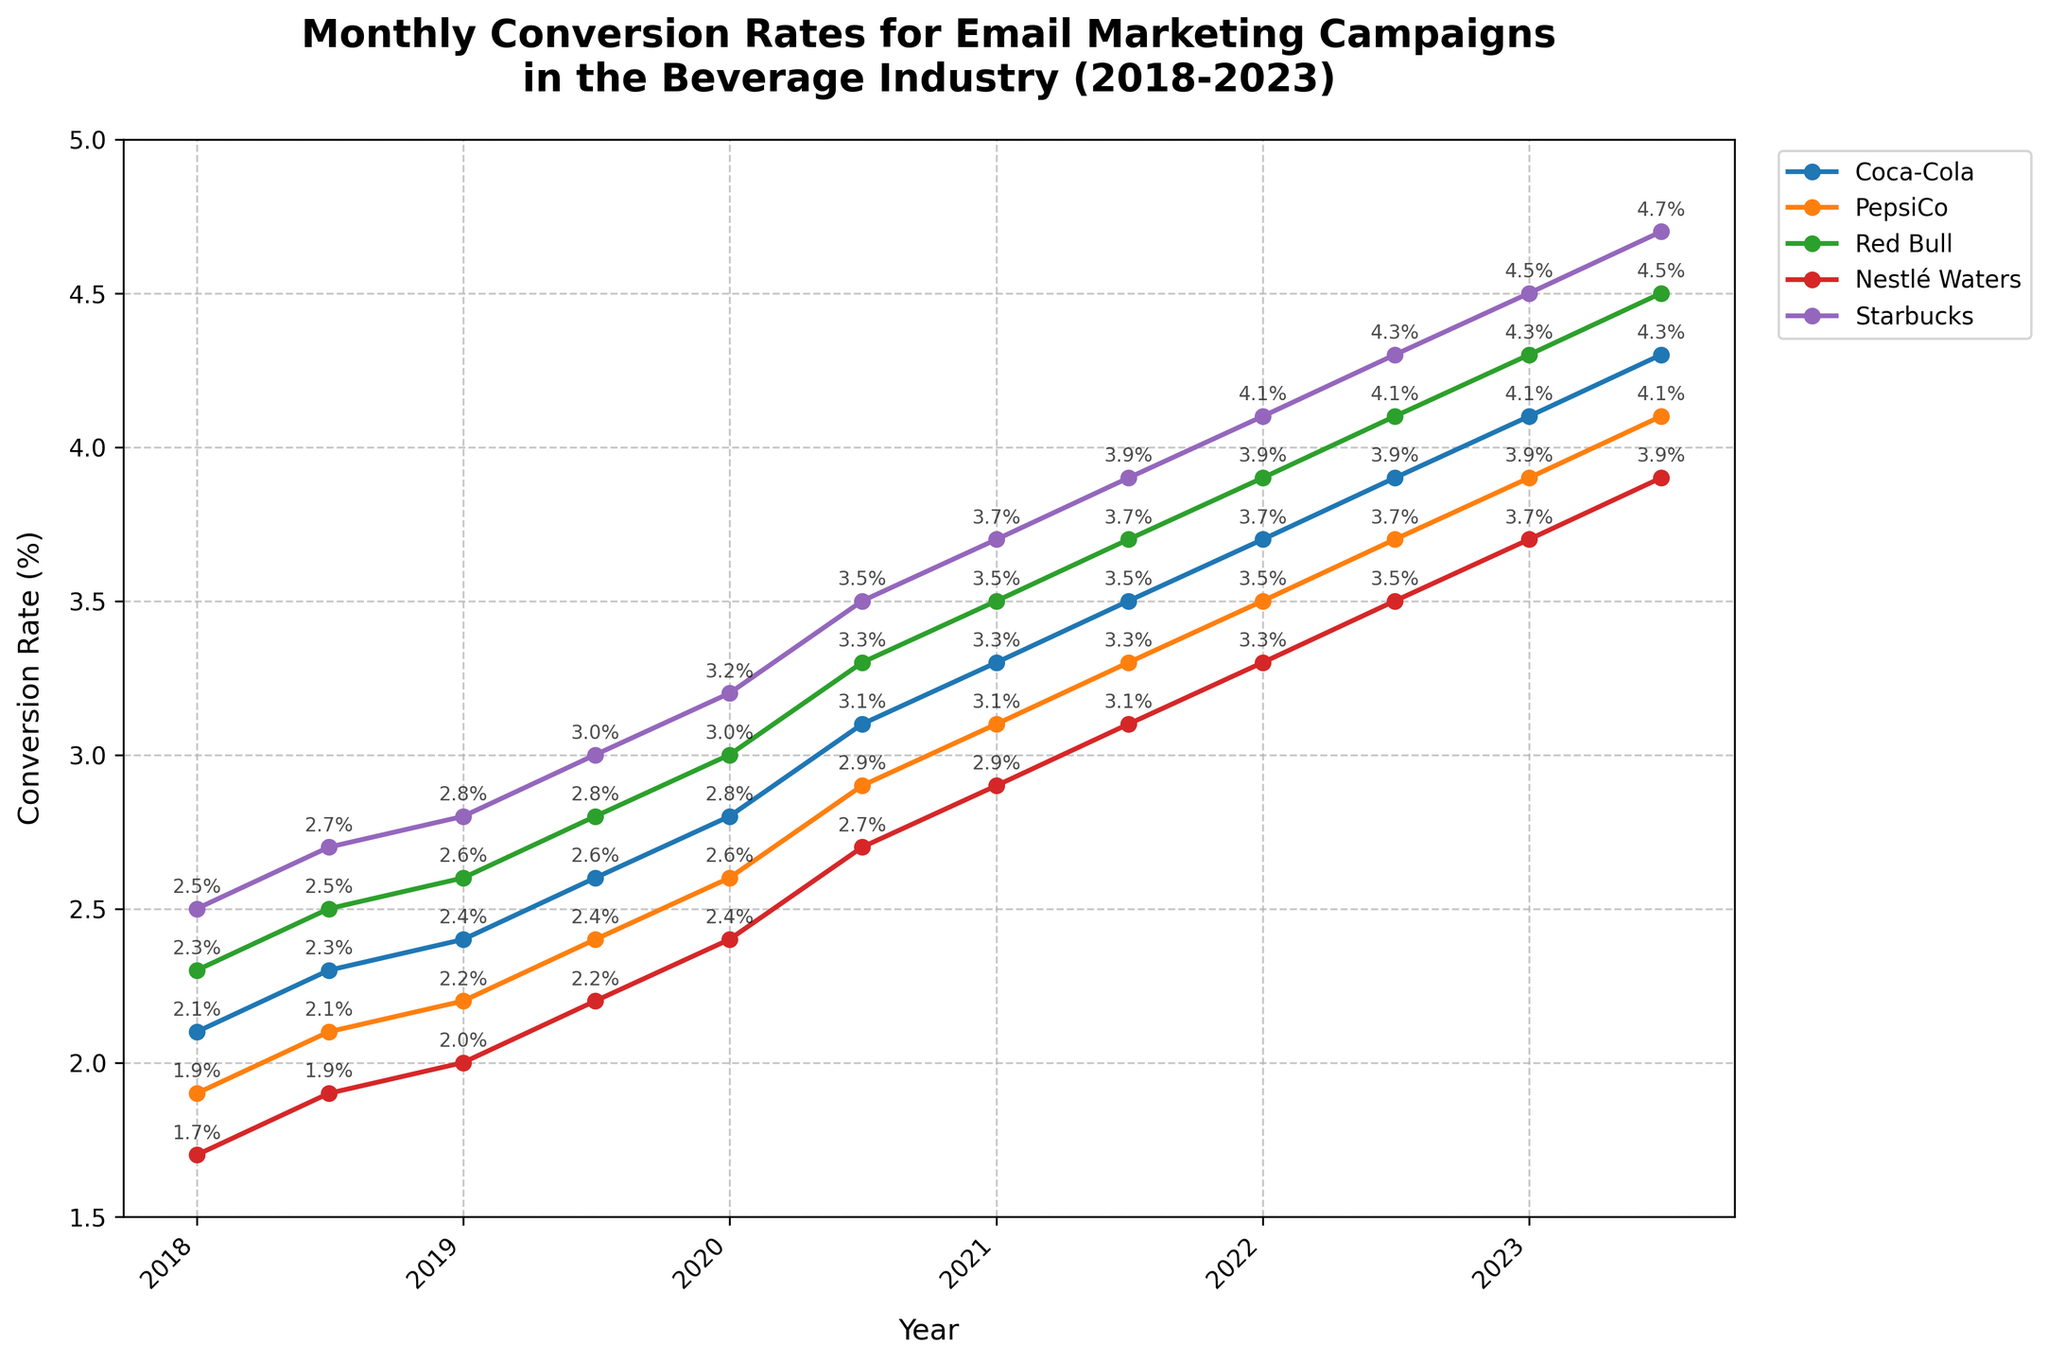What is the highest conversion rate observed for PepsiCo within the timeframe? To find the highest conversion rate for PepsiCo, we scan the PepsiCo values across all the months shown in the chart. The highest value is 4.1% in July 2023.
Answer: 4.1% Which company experienced the greatest increase in conversion rate from January 2018 to July 2023? By comparing the conversion rates from January 2018 and July 2023 for each company, we calculate the increase for: Coca-Cola (4.3 - 2.1 = 2.2), PepsiCo (4.1 - 1.9 = 2.2), Red Bull (4.5 - 2.3 = 2.2), Nestlé Waters (3.9 - 1.7 = 2.2), and Starbucks (4.7 - 2.5 = 2.2). All companies have the same increase of 2.2%.
Answer: All companies What's the average conversion rate for Starbucks across the whole period? Sum the conversion rates for Starbucks from Jan 2018 to Jul 2023 (2.5 + 2.7 + 2.8 + 3.0 + 3.2 + 3.5 + 3.7 + 3.9 + 4.1 + 4.3 + 4.5 + 4.7 = 43.9) and divide by the number of data points (43.9 / 12 = 3.6583).
Answer: 3.66% During July 2020, which company had the lowest conversion rate, and what was it? Check the conversion rates for all companies in July 2020. Coca-Cola: 3.1, PepsiCo: 2.9, Red Bull: 3.3, Nestlé Waters: 2.7, Starbucks: 3.5. Nestlé Waters has the lowest rate of 2.7%.
Answer: Nestlé Waters, 2.7% Which two companies had identical conversion rates at any point, and when was this? From the graph, note any identical conversion rates. Coca-Cola and PepsiCo both had a rate of 4.1% in July 2023.
Answer: Coca-Cola and PepsiCo, July 2023 What is the median conversion rate for Nestlé Waters throughout the observed period? List all conversion rates for Nestlé Waters (1.7, 1.9, 2.0, 2.2, 2.4, 2.7, 2.9, 3.1, 3.3, 3.5, 3.7, 3.9), arrange them in order, then find the middle values (2.7 and 2.9). Hence, the median is (2.7 + 2.9) / 2 = 2.8.
Answer: 2.8 In which year did Coca-Cola surpass a 3% conversion rate for the first time? Scan through the conversion rates for Coca-Cola until it exceeds 3%. It first surpasses 3% in January 2020 with a rate of 3.1%.
Answer: 2020 How many companies had a higher conversion rate than Red Bull in January 2022? Compare other companies' conversion rates with Red Bull's in January 2022 (3.9): Coca-Cola (3.7), PepsiCo (3.5), Nestlé Waters (3.3), and Starbucks (4.1). One company, Starbucks, had a higher rate.
Answer: 1 company Between Jan 2018 and Jul 2023, which company had the most significant relative improvement in conversion rates? Calculate the percentage increase from Jan 2018 to Jul 2023 for each company: Coca-Cola ((4.3-2.1)/2.1)*100 = 104.76%, PepsiCo ((4.1-1.9)/1.9)*100 = 115.79%, Red Bull ((4.5-2.3)/2.3)*100 = 95.65%, Nestlé Waters ((3.9-1.7)/1.7)*100 = 129.41%, Starbucks ((4.7-2.5)/2.5)*100 = 88%. Nestlé Waters had the highest relative improvement.
Answer: Nestlé Waters Comparing January 2022 and July 2022, which company saw the most significant increase in conversion rates? Calculate the difference for each company from Jan 2022 to Jul 2022: Coca-Cola (3.9-3.7 = 0.2), PepsiCo (3.7-3.5 = 0.2), Red Bull (4.1-3.9 = 0.2), Nestlé Waters (3.5-3.3 = 0.2), Starbucks (4.3-4.1 = 0.2). All companies show an increase of 0.2.
Answer: All companies 